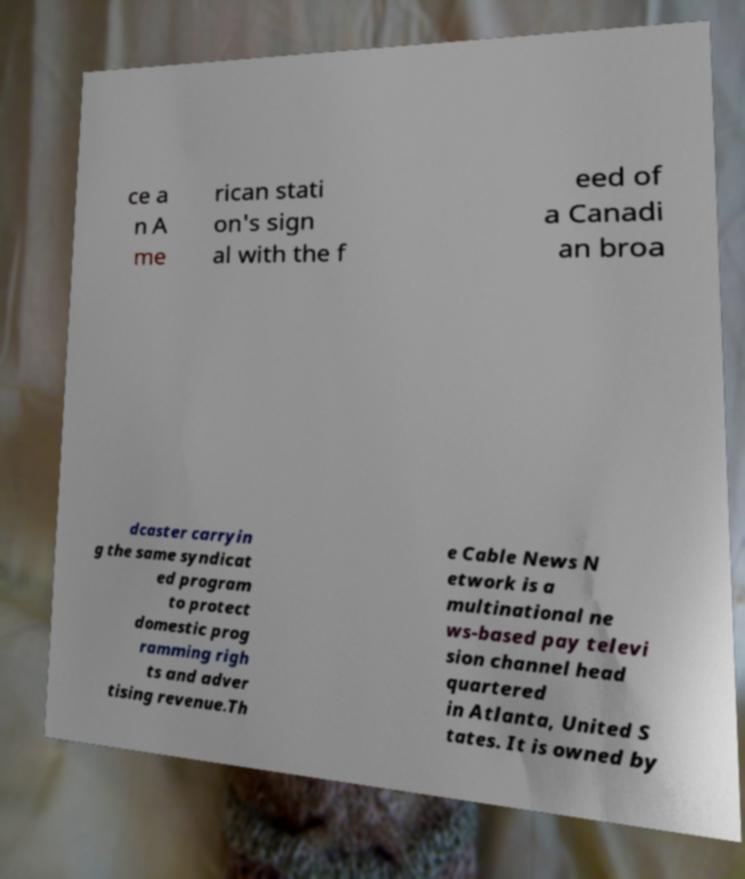There's text embedded in this image that I need extracted. Can you transcribe it verbatim? ce a n A me rican stati on's sign al with the f eed of a Canadi an broa dcaster carryin g the same syndicat ed program to protect domestic prog ramming righ ts and adver tising revenue.Th e Cable News N etwork is a multinational ne ws-based pay televi sion channel head quartered in Atlanta, United S tates. It is owned by 